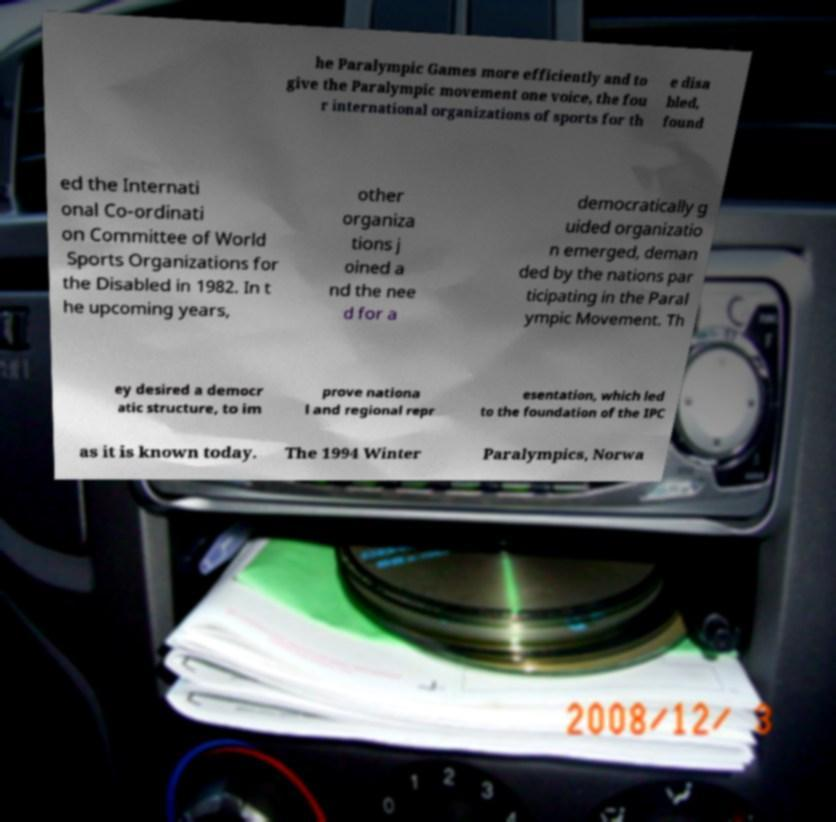I need the written content from this picture converted into text. Can you do that? he Paralympic Games more efficiently and to give the Paralympic movement one voice, the fou r international organizations of sports for th e disa bled, found ed the Internati onal Co-ordinati on Committee of World Sports Organizations for the Disabled in 1982. In t he upcoming years, other organiza tions j oined a nd the nee d for a democratically g uided organizatio n emerged, deman ded by the nations par ticipating in the Paral ympic Movement. Th ey desired a democr atic structure, to im prove nationa l and regional repr esentation, which led to the foundation of the IPC as it is known today. The 1994 Winter Paralympics, Norwa 